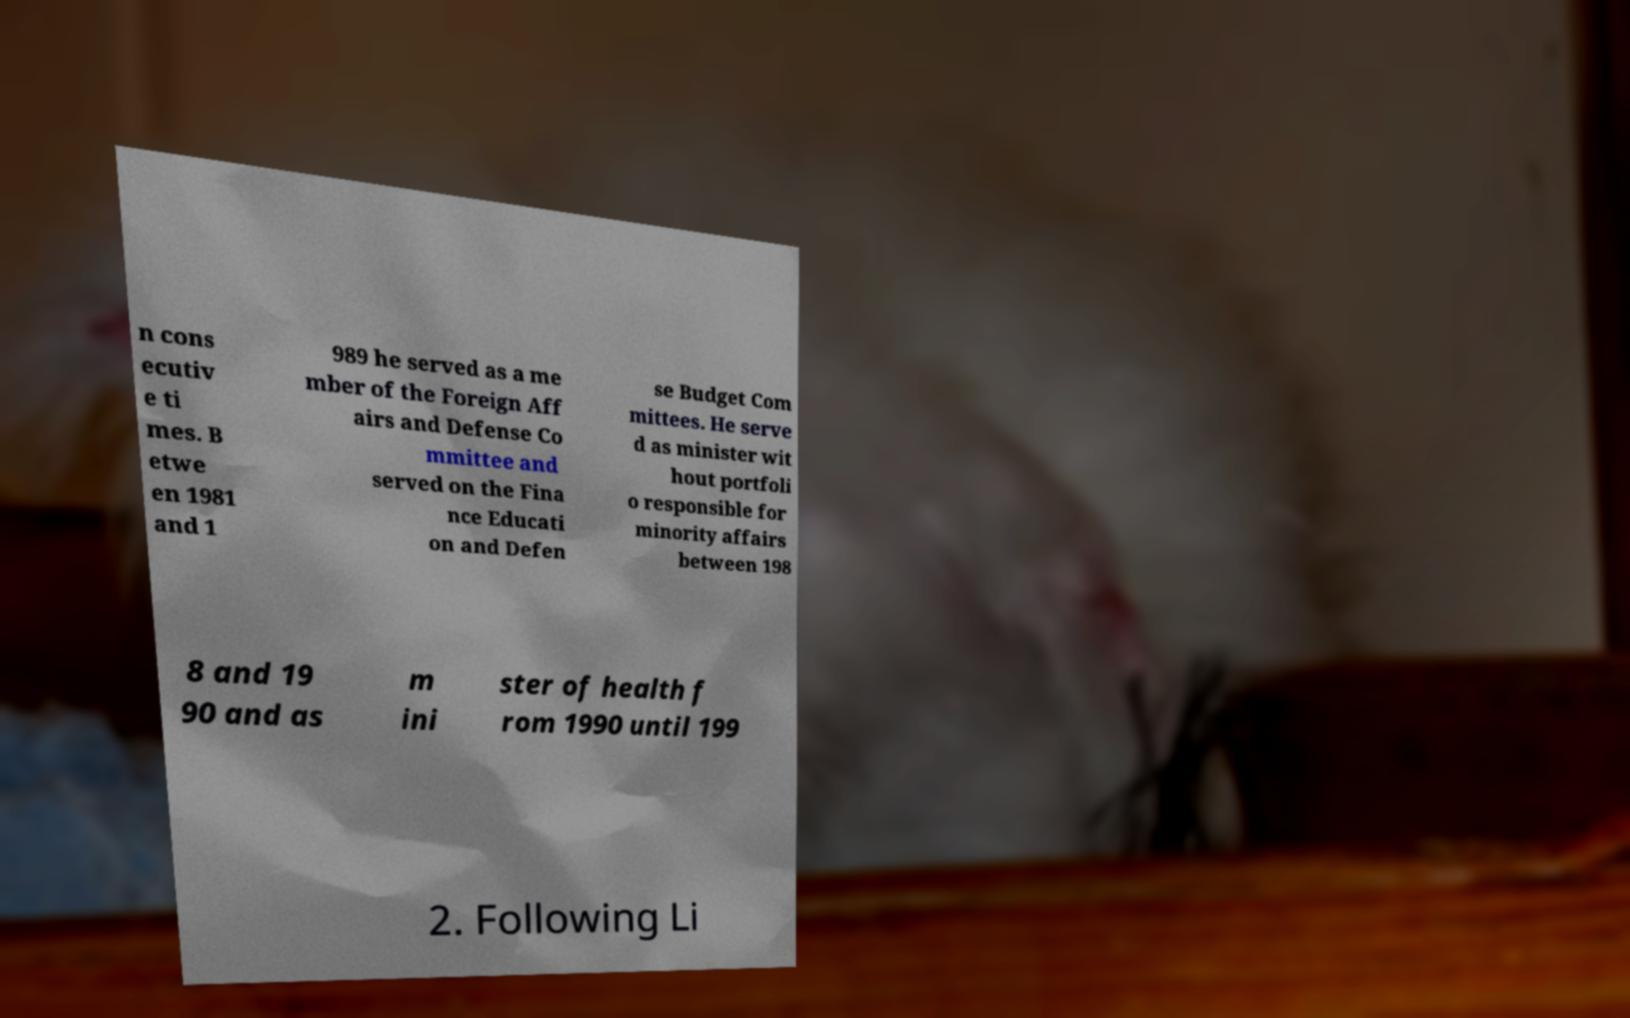For documentation purposes, I need the text within this image transcribed. Could you provide that? n cons ecutiv e ti mes. B etwe en 1981 and 1 989 he served as a me mber of the Foreign Aff airs and Defense Co mmittee and served on the Fina nce Educati on and Defen se Budget Com mittees. He serve d as minister wit hout portfoli o responsible for minority affairs between 198 8 and 19 90 and as m ini ster of health f rom 1990 until 199 2. Following Li 